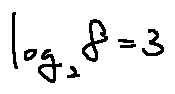Convert formula to latex. <formula><loc_0><loc_0><loc_500><loc_500>\log _ { 2 } 8 = 3</formula> 